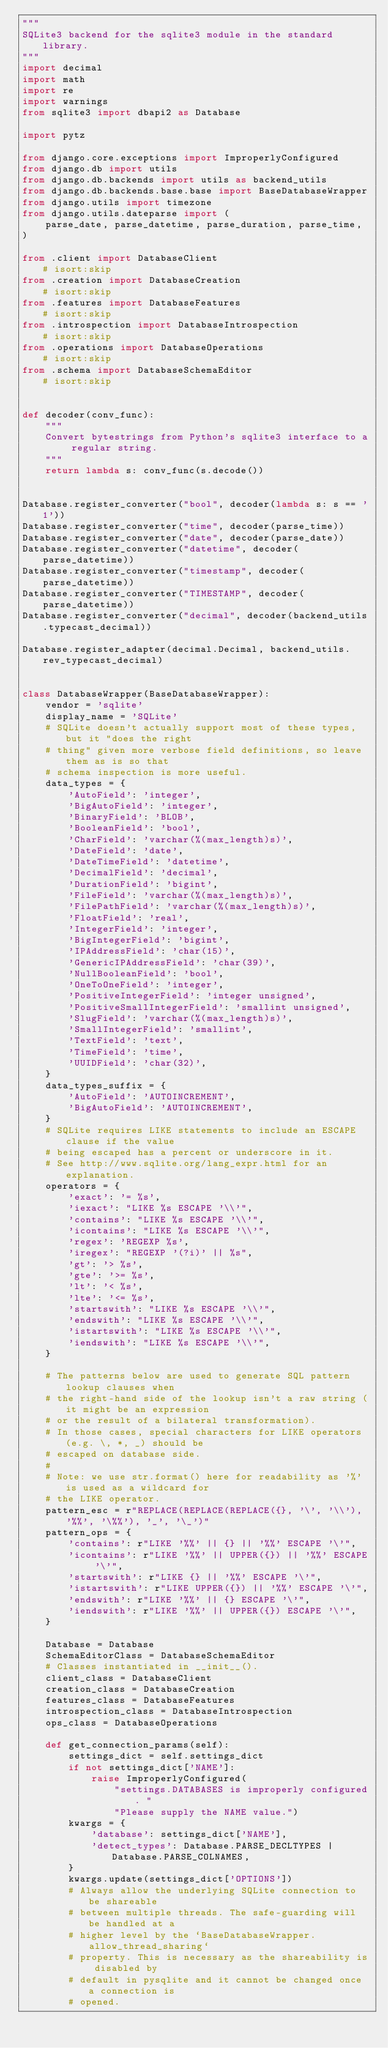Convert code to text. <code><loc_0><loc_0><loc_500><loc_500><_Python_>"""
SQLite3 backend for the sqlite3 module in the standard library.
"""
import decimal
import math
import re
import warnings
from sqlite3 import dbapi2 as Database

import pytz

from django.core.exceptions import ImproperlyConfigured
from django.db import utils
from django.db.backends import utils as backend_utils
from django.db.backends.base.base import BaseDatabaseWrapper
from django.utils import timezone
from django.utils.dateparse import (
    parse_date, parse_datetime, parse_duration, parse_time,
)

from .client import DatabaseClient                          # isort:skip
from .creation import DatabaseCreation                      # isort:skip
from .features import DatabaseFeatures                      # isort:skip
from .introspection import DatabaseIntrospection            # isort:skip
from .operations import DatabaseOperations                  # isort:skip
from .schema import DatabaseSchemaEditor                    # isort:skip


def decoder(conv_func):
    """
    Convert bytestrings from Python's sqlite3 interface to a regular string.
    """
    return lambda s: conv_func(s.decode())


Database.register_converter("bool", decoder(lambda s: s == '1'))
Database.register_converter("time", decoder(parse_time))
Database.register_converter("date", decoder(parse_date))
Database.register_converter("datetime", decoder(parse_datetime))
Database.register_converter("timestamp", decoder(parse_datetime))
Database.register_converter("TIMESTAMP", decoder(parse_datetime))
Database.register_converter("decimal", decoder(backend_utils.typecast_decimal))

Database.register_adapter(decimal.Decimal, backend_utils.rev_typecast_decimal)


class DatabaseWrapper(BaseDatabaseWrapper):
    vendor = 'sqlite'
    display_name = 'SQLite'
    # SQLite doesn't actually support most of these types, but it "does the right
    # thing" given more verbose field definitions, so leave them as is so that
    # schema inspection is more useful.
    data_types = {
        'AutoField': 'integer',
        'BigAutoField': 'integer',
        'BinaryField': 'BLOB',
        'BooleanField': 'bool',
        'CharField': 'varchar(%(max_length)s)',
        'DateField': 'date',
        'DateTimeField': 'datetime',
        'DecimalField': 'decimal',
        'DurationField': 'bigint',
        'FileField': 'varchar(%(max_length)s)',
        'FilePathField': 'varchar(%(max_length)s)',
        'FloatField': 'real',
        'IntegerField': 'integer',
        'BigIntegerField': 'bigint',
        'IPAddressField': 'char(15)',
        'GenericIPAddressField': 'char(39)',
        'NullBooleanField': 'bool',
        'OneToOneField': 'integer',
        'PositiveIntegerField': 'integer unsigned',
        'PositiveSmallIntegerField': 'smallint unsigned',
        'SlugField': 'varchar(%(max_length)s)',
        'SmallIntegerField': 'smallint',
        'TextField': 'text',
        'TimeField': 'time',
        'UUIDField': 'char(32)',
    }
    data_types_suffix = {
        'AutoField': 'AUTOINCREMENT',
        'BigAutoField': 'AUTOINCREMENT',
    }
    # SQLite requires LIKE statements to include an ESCAPE clause if the value
    # being escaped has a percent or underscore in it.
    # See http://www.sqlite.org/lang_expr.html for an explanation.
    operators = {
        'exact': '= %s',
        'iexact': "LIKE %s ESCAPE '\\'",
        'contains': "LIKE %s ESCAPE '\\'",
        'icontains': "LIKE %s ESCAPE '\\'",
        'regex': 'REGEXP %s',
        'iregex': "REGEXP '(?i)' || %s",
        'gt': '> %s',
        'gte': '>= %s',
        'lt': '< %s',
        'lte': '<= %s',
        'startswith': "LIKE %s ESCAPE '\\'",
        'endswith': "LIKE %s ESCAPE '\\'",
        'istartswith': "LIKE %s ESCAPE '\\'",
        'iendswith': "LIKE %s ESCAPE '\\'",
    }

    # The patterns below are used to generate SQL pattern lookup clauses when
    # the right-hand side of the lookup isn't a raw string (it might be an expression
    # or the result of a bilateral transformation).
    # In those cases, special characters for LIKE operators (e.g. \, *, _) should be
    # escaped on database side.
    #
    # Note: we use str.format() here for readability as '%' is used as a wildcard for
    # the LIKE operator.
    pattern_esc = r"REPLACE(REPLACE(REPLACE({}, '\', '\\'), '%%', '\%%'), '_', '\_')"
    pattern_ops = {
        'contains': r"LIKE '%%' || {} || '%%' ESCAPE '\'",
        'icontains': r"LIKE '%%' || UPPER({}) || '%%' ESCAPE '\'",
        'startswith': r"LIKE {} || '%%' ESCAPE '\'",
        'istartswith': r"LIKE UPPER({}) || '%%' ESCAPE '\'",
        'endswith': r"LIKE '%%' || {} ESCAPE '\'",
        'iendswith': r"LIKE '%%' || UPPER({}) ESCAPE '\'",
    }

    Database = Database
    SchemaEditorClass = DatabaseSchemaEditor
    # Classes instantiated in __init__().
    client_class = DatabaseClient
    creation_class = DatabaseCreation
    features_class = DatabaseFeatures
    introspection_class = DatabaseIntrospection
    ops_class = DatabaseOperations

    def get_connection_params(self):
        settings_dict = self.settings_dict
        if not settings_dict['NAME']:
            raise ImproperlyConfigured(
                "settings.DATABASES is improperly configured. "
                "Please supply the NAME value.")
        kwargs = {
            'database': settings_dict['NAME'],
            'detect_types': Database.PARSE_DECLTYPES | Database.PARSE_COLNAMES,
        }
        kwargs.update(settings_dict['OPTIONS'])
        # Always allow the underlying SQLite connection to be shareable
        # between multiple threads. The safe-guarding will be handled at a
        # higher level by the `BaseDatabaseWrapper.allow_thread_sharing`
        # property. This is necessary as the shareability is disabled by
        # default in pysqlite and it cannot be changed once a connection is
        # opened.</code> 